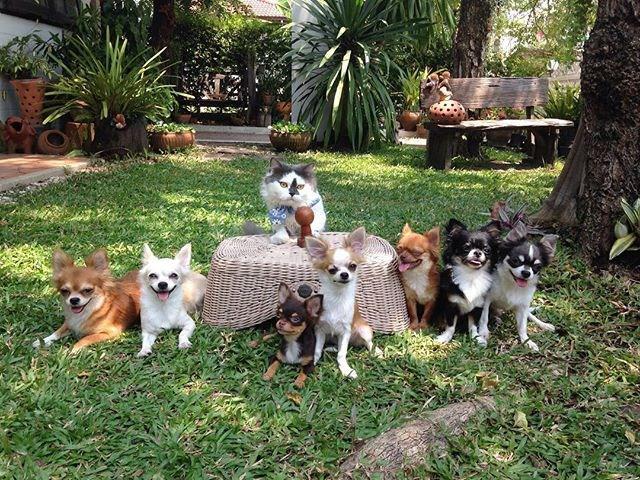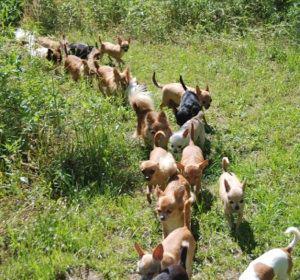The first image is the image on the left, the second image is the image on the right. For the images shown, is this caption "A cat is in the middle of a horizontal row of dogs in one image." true? Answer yes or no. Yes. The first image is the image on the left, the second image is the image on the right. Given the left and right images, does the statement "There are five dogs in the left picture." hold true? Answer yes or no. No. 